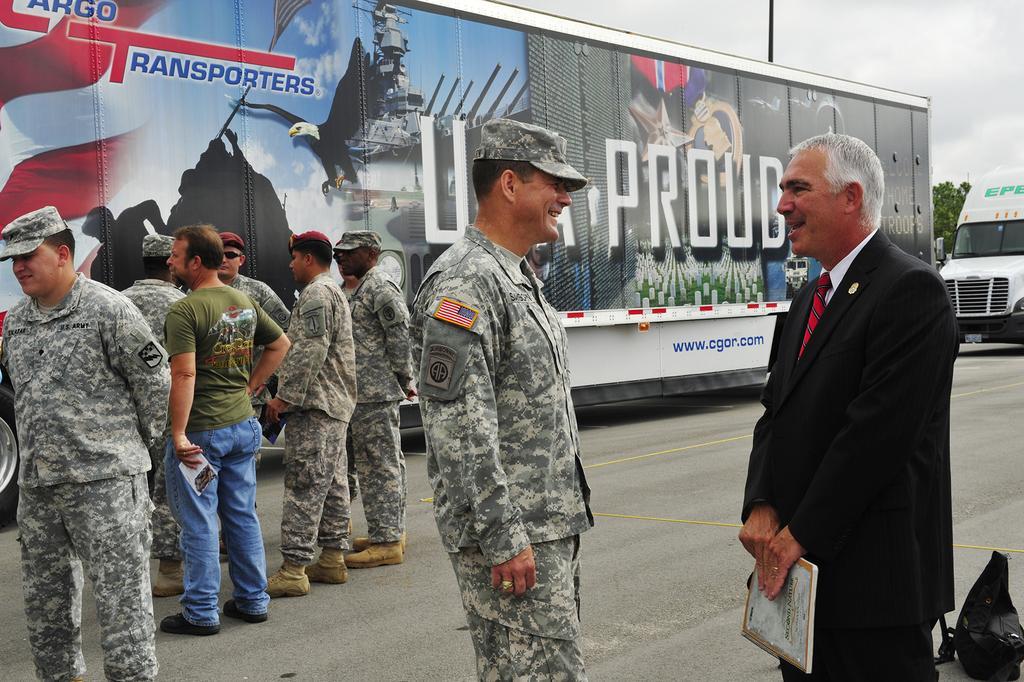Please provide a concise description of this image. In this picture there are people standing and we can see vehicles and bag on the road. In the background of the image we can see leaves, pole and sky. 